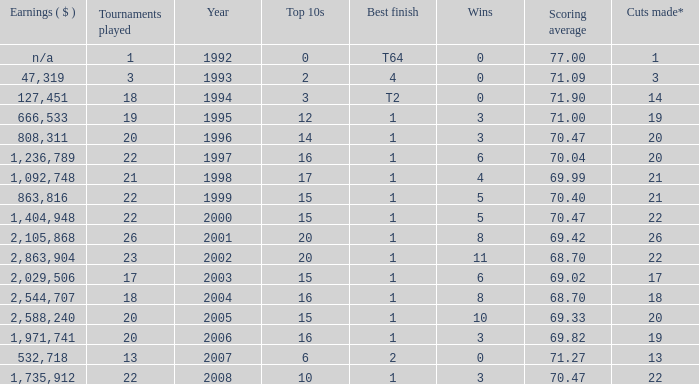Tell me the scoring average for year less than 1998 and wins more than 3 70.04. 